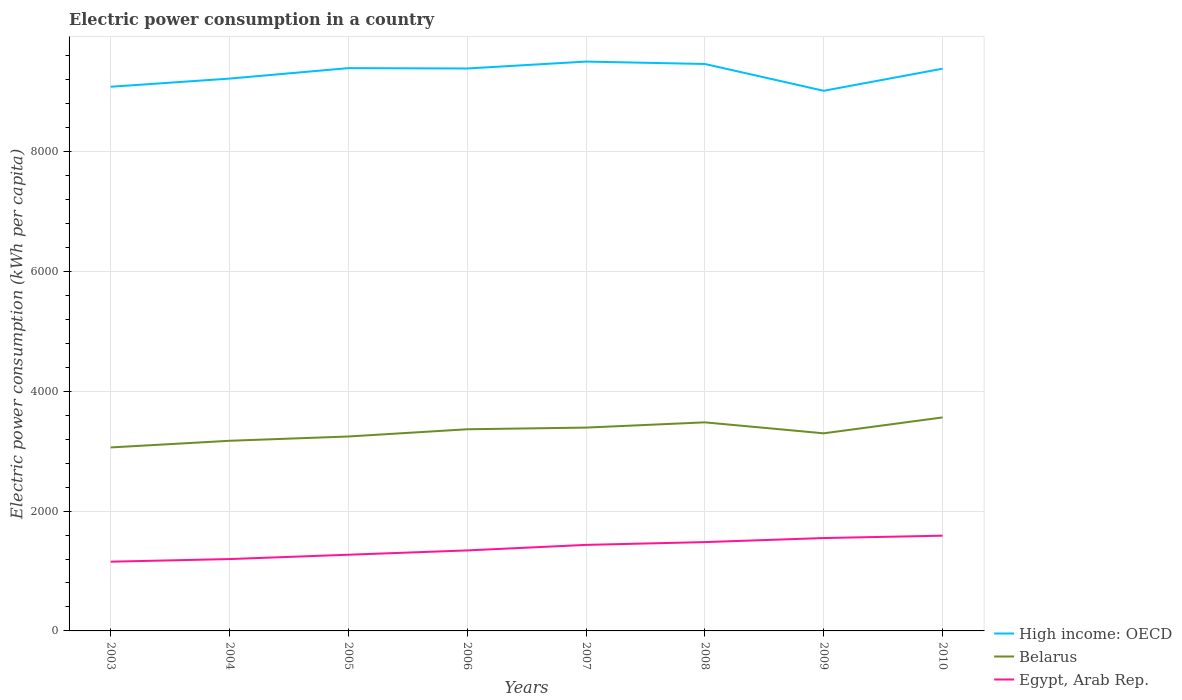How many different coloured lines are there?
Make the answer very short. 3. Is the number of lines equal to the number of legend labels?
Offer a terse response. Yes. Across all years, what is the maximum electric power consumption in in High income: OECD?
Your answer should be compact. 9016.62. In which year was the electric power consumption in in High income: OECD maximum?
Provide a succinct answer. 2009. What is the total electric power consumption in in Egypt, Arab Rep. in the graph?
Ensure brevity in your answer.  -236.49. What is the difference between the highest and the second highest electric power consumption in in Egypt, Arab Rep.?
Offer a very short reply. 434.06. What is the difference between two consecutive major ticks on the Y-axis?
Your answer should be compact. 2000. Are the values on the major ticks of Y-axis written in scientific E-notation?
Ensure brevity in your answer.  No. Where does the legend appear in the graph?
Give a very brief answer. Bottom right. How are the legend labels stacked?
Offer a very short reply. Vertical. What is the title of the graph?
Offer a terse response. Electric power consumption in a country. What is the label or title of the X-axis?
Make the answer very short. Years. What is the label or title of the Y-axis?
Offer a terse response. Electric power consumption (kWh per capita). What is the Electric power consumption (kWh per capita) of High income: OECD in 2003?
Your response must be concise. 9084.07. What is the Electric power consumption (kWh per capita) of Belarus in 2003?
Provide a short and direct response. 3062.98. What is the Electric power consumption (kWh per capita) in Egypt, Arab Rep. in 2003?
Your response must be concise. 1155.82. What is the Electric power consumption (kWh per capita) of High income: OECD in 2004?
Your answer should be very brief. 9220.23. What is the Electric power consumption (kWh per capita) in Belarus in 2004?
Ensure brevity in your answer.  3174.1. What is the Electric power consumption (kWh per capita) in Egypt, Arab Rep. in 2004?
Your response must be concise. 1199.59. What is the Electric power consumption (kWh per capita) of High income: OECD in 2005?
Provide a succinct answer. 9394.97. What is the Electric power consumption (kWh per capita) in Belarus in 2005?
Offer a very short reply. 3245.68. What is the Electric power consumption (kWh per capita) of Egypt, Arab Rep. in 2005?
Ensure brevity in your answer.  1271.75. What is the Electric power consumption (kWh per capita) in High income: OECD in 2006?
Make the answer very short. 9388.91. What is the Electric power consumption (kWh per capita) of Belarus in 2006?
Make the answer very short. 3366.31. What is the Electric power consumption (kWh per capita) of Egypt, Arab Rep. in 2006?
Your answer should be very brief. 1343.77. What is the Electric power consumption (kWh per capita) of High income: OECD in 2007?
Your answer should be compact. 9504.23. What is the Electric power consumption (kWh per capita) in Belarus in 2007?
Your answer should be very brief. 3394.25. What is the Electric power consumption (kWh per capita) in Egypt, Arab Rep. in 2007?
Keep it short and to the point. 1436.07. What is the Electric power consumption (kWh per capita) of High income: OECD in 2008?
Provide a short and direct response. 9464.13. What is the Electric power consumption (kWh per capita) in Belarus in 2008?
Provide a short and direct response. 3481.74. What is the Electric power consumption (kWh per capita) in Egypt, Arab Rep. in 2008?
Your answer should be very brief. 1482.85. What is the Electric power consumption (kWh per capita) of High income: OECD in 2009?
Your response must be concise. 9016.62. What is the Electric power consumption (kWh per capita) in Belarus in 2009?
Ensure brevity in your answer.  3298.62. What is the Electric power consumption (kWh per capita) of Egypt, Arab Rep. in 2009?
Provide a short and direct response. 1550.49. What is the Electric power consumption (kWh per capita) of High income: OECD in 2010?
Offer a very short reply. 9385.25. What is the Electric power consumption (kWh per capita) in Belarus in 2010?
Ensure brevity in your answer.  3563.86. What is the Electric power consumption (kWh per capita) in Egypt, Arab Rep. in 2010?
Offer a very short reply. 1589.88. Across all years, what is the maximum Electric power consumption (kWh per capita) in High income: OECD?
Provide a succinct answer. 9504.23. Across all years, what is the maximum Electric power consumption (kWh per capita) in Belarus?
Your answer should be very brief. 3563.86. Across all years, what is the maximum Electric power consumption (kWh per capita) in Egypt, Arab Rep.?
Offer a terse response. 1589.88. Across all years, what is the minimum Electric power consumption (kWh per capita) in High income: OECD?
Make the answer very short. 9016.62. Across all years, what is the minimum Electric power consumption (kWh per capita) in Belarus?
Keep it short and to the point. 3062.98. Across all years, what is the minimum Electric power consumption (kWh per capita) in Egypt, Arab Rep.?
Offer a terse response. 1155.82. What is the total Electric power consumption (kWh per capita) in High income: OECD in the graph?
Offer a very short reply. 7.45e+04. What is the total Electric power consumption (kWh per capita) of Belarus in the graph?
Your answer should be compact. 2.66e+04. What is the total Electric power consumption (kWh per capita) in Egypt, Arab Rep. in the graph?
Your answer should be very brief. 1.10e+04. What is the difference between the Electric power consumption (kWh per capita) of High income: OECD in 2003 and that in 2004?
Keep it short and to the point. -136.15. What is the difference between the Electric power consumption (kWh per capita) of Belarus in 2003 and that in 2004?
Your answer should be compact. -111.12. What is the difference between the Electric power consumption (kWh per capita) of Egypt, Arab Rep. in 2003 and that in 2004?
Offer a very short reply. -43.77. What is the difference between the Electric power consumption (kWh per capita) in High income: OECD in 2003 and that in 2005?
Provide a short and direct response. -310.9. What is the difference between the Electric power consumption (kWh per capita) in Belarus in 2003 and that in 2005?
Make the answer very short. -182.7. What is the difference between the Electric power consumption (kWh per capita) of Egypt, Arab Rep. in 2003 and that in 2005?
Provide a short and direct response. -115.94. What is the difference between the Electric power consumption (kWh per capita) of High income: OECD in 2003 and that in 2006?
Your response must be concise. -304.84. What is the difference between the Electric power consumption (kWh per capita) in Belarus in 2003 and that in 2006?
Provide a short and direct response. -303.33. What is the difference between the Electric power consumption (kWh per capita) of Egypt, Arab Rep. in 2003 and that in 2006?
Provide a succinct answer. -187.95. What is the difference between the Electric power consumption (kWh per capita) in High income: OECD in 2003 and that in 2007?
Make the answer very short. -420.15. What is the difference between the Electric power consumption (kWh per capita) in Belarus in 2003 and that in 2007?
Your answer should be compact. -331.27. What is the difference between the Electric power consumption (kWh per capita) in Egypt, Arab Rep. in 2003 and that in 2007?
Your answer should be very brief. -280.26. What is the difference between the Electric power consumption (kWh per capita) of High income: OECD in 2003 and that in 2008?
Offer a terse response. -380.05. What is the difference between the Electric power consumption (kWh per capita) of Belarus in 2003 and that in 2008?
Keep it short and to the point. -418.76. What is the difference between the Electric power consumption (kWh per capita) of Egypt, Arab Rep. in 2003 and that in 2008?
Keep it short and to the point. -327.04. What is the difference between the Electric power consumption (kWh per capita) of High income: OECD in 2003 and that in 2009?
Provide a short and direct response. 67.46. What is the difference between the Electric power consumption (kWh per capita) of Belarus in 2003 and that in 2009?
Your answer should be very brief. -235.64. What is the difference between the Electric power consumption (kWh per capita) of Egypt, Arab Rep. in 2003 and that in 2009?
Provide a short and direct response. -394.67. What is the difference between the Electric power consumption (kWh per capita) of High income: OECD in 2003 and that in 2010?
Provide a short and direct response. -301.18. What is the difference between the Electric power consumption (kWh per capita) of Belarus in 2003 and that in 2010?
Provide a short and direct response. -500.88. What is the difference between the Electric power consumption (kWh per capita) in Egypt, Arab Rep. in 2003 and that in 2010?
Keep it short and to the point. -434.06. What is the difference between the Electric power consumption (kWh per capita) in High income: OECD in 2004 and that in 2005?
Provide a short and direct response. -174.75. What is the difference between the Electric power consumption (kWh per capita) in Belarus in 2004 and that in 2005?
Provide a short and direct response. -71.58. What is the difference between the Electric power consumption (kWh per capita) in Egypt, Arab Rep. in 2004 and that in 2005?
Give a very brief answer. -72.17. What is the difference between the Electric power consumption (kWh per capita) in High income: OECD in 2004 and that in 2006?
Your answer should be compact. -168.69. What is the difference between the Electric power consumption (kWh per capita) in Belarus in 2004 and that in 2006?
Make the answer very short. -192.21. What is the difference between the Electric power consumption (kWh per capita) of Egypt, Arab Rep. in 2004 and that in 2006?
Make the answer very short. -144.18. What is the difference between the Electric power consumption (kWh per capita) in High income: OECD in 2004 and that in 2007?
Ensure brevity in your answer.  -284. What is the difference between the Electric power consumption (kWh per capita) in Belarus in 2004 and that in 2007?
Provide a succinct answer. -220.15. What is the difference between the Electric power consumption (kWh per capita) of Egypt, Arab Rep. in 2004 and that in 2007?
Offer a very short reply. -236.49. What is the difference between the Electric power consumption (kWh per capita) of High income: OECD in 2004 and that in 2008?
Make the answer very short. -243.9. What is the difference between the Electric power consumption (kWh per capita) in Belarus in 2004 and that in 2008?
Ensure brevity in your answer.  -307.64. What is the difference between the Electric power consumption (kWh per capita) of Egypt, Arab Rep. in 2004 and that in 2008?
Provide a succinct answer. -283.26. What is the difference between the Electric power consumption (kWh per capita) of High income: OECD in 2004 and that in 2009?
Offer a very short reply. 203.61. What is the difference between the Electric power consumption (kWh per capita) in Belarus in 2004 and that in 2009?
Offer a very short reply. -124.52. What is the difference between the Electric power consumption (kWh per capita) of Egypt, Arab Rep. in 2004 and that in 2009?
Keep it short and to the point. -350.9. What is the difference between the Electric power consumption (kWh per capita) in High income: OECD in 2004 and that in 2010?
Keep it short and to the point. -165.02. What is the difference between the Electric power consumption (kWh per capita) of Belarus in 2004 and that in 2010?
Your response must be concise. -389.76. What is the difference between the Electric power consumption (kWh per capita) in Egypt, Arab Rep. in 2004 and that in 2010?
Provide a succinct answer. -390.29. What is the difference between the Electric power consumption (kWh per capita) in High income: OECD in 2005 and that in 2006?
Offer a terse response. 6.06. What is the difference between the Electric power consumption (kWh per capita) in Belarus in 2005 and that in 2006?
Ensure brevity in your answer.  -120.63. What is the difference between the Electric power consumption (kWh per capita) in Egypt, Arab Rep. in 2005 and that in 2006?
Provide a succinct answer. -72.01. What is the difference between the Electric power consumption (kWh per capita) of High income: OECD in 2005 and that in 2007?
Provide a succinct answer. -109.25. What is the difference between the Electric power consumption (kWh per capita) in Belarus in 2005 and that in 2007?
Your response must be concise. -148.57. What is the difference between the Electric power consumption (kWh per capita) in Egypt, Arab Rep. in 2005 and that in 2007?
Your answer should be compact. -164.32. What is the difference between the Electric power consumption (kWh per capita) in High income: OECD in 2005 and that in 2008?
Ensure brevity in your answer.  -69.16. What is the difference between the Electric power consumption (kWh per capita) of Belarus in 2005 and that in 2008?
Make the answer very short. -236.06. What is the difference between the Electric power consumption (kWh per capita) of Egypt, Arab Rep. in 2005 and that in 2008?
Keep it short and to the point. -211.1. What is the difference between the Electric power consumption (kWh per capita) in High income: OECD in 2005 and that in 2009?
Make the answer very short. 378.36. What is the difference between the Electric power consumption (kWh per capita) in Belarus in 2005 and that in 2009?
Offer a very short reply. -52.94. What is the difference between the Electric power consumption (kWh per capita) of Egypt, Arab Rep. in 2005 and that in 2009?
Offer a terse response. -278.73. What is the difference between the Electric power consumption (kWh per capita) in High income: OECD in 2005 and that in 2010?
Offer a terse response. 9.72. What is the difference between the Electric power consumption (kWh per capita) of Belarus in 2005 and that in 2010?
Ensure brevity in your answer.  -318.18. What is the difference between the Electric power consumption (kWh per capita) in Egypt, Arab Rep. in 2005 and that in 2010?
Offer a very short reply. -318.12. What is the difference between the Electric power consumption (kWh per capita) of High income: OECD in 2006 and that in 2007?
Keep it short and to the point. -115.31. What is the difference between the Electric power consumption (kWh per capita) of Belarus in 2006 and that in 2007?
Provide a short and direct response. -27.94. What is the difference between the Electric power consumption (kWh per capita) of Egypt, Arab Rep. in 2006 and that in 2007?
Your answer should be very brief. -92.31. What is the difference between the Electric power consumption (kWh per capita) in High income: OECD in 2006 and that in 2008?
Your answer should be very brief. -75.21. What is the difference between the Electric power consumption (kWh per capita) of Belarus in 2006 and that in 2008?
Provide a short and direct response. -115.43. What is the difference between the Electric power consumption (kWh per capita) in Egypt, Arab Rep. in 2006 and that in 2008?
Keep it short and to the point. -139.08. What is the difference between the Electric power consumption (kWh per capita) in High income: OECD in 2006 and that in 2009?
Offer a very short reply. 372.3. What is the difference between the Electric power consumption (kWh per capita) of Belarus in 2006 and that in 2009?
Your answer should be compact. 67.68. What is the difference between the Electric power consumption (kWh per capita) in Egypt, Arab Rep. in 2006 and that in 2009?
Provide a succinct answer. -206.72. What is the difference between the Electric power consumption (kWh per capita) of High income: OECD in 2006 and that in 2010?
Give a very brief answer. 3.66. What is the difference between the Electric power consumption (kWh per capita) of Belarus in 2006 and that in 2010?
Your answer should be compact. -197.55. What is the difference between the Electric power consumption (kWh per capita) in Egypt, Arab Rep. in 2006 and that in 2010?
Offer a terse response. -246.11. What is the difference between the Electric power consumption (kWh per capita) in High income: OECD in 2007 and that in 2008?
Your response must be concise. 40.1. What is the difference between the Electric power consumption (kWh per capita) in Belarus in 2007 and that in 2008?
Provide a succinct answer. -87.49. What is the difference between the Electric power consumption (kWh per capita) in Egypt, Arab Rep. in 2007 and that in 2008?
Offer a very short reply. -46.78. What is the difference between the Electric power consumption (kWh per capita) of High income: OECD in 2007 and that in 2009?
Your response must be concise. 487.61. What is the difference between the Electric power consumption (kWh per capita) in Belarus in 2007 and that in 2009?
Make the answer very short. 95.62. What is the difference between the Electric power consumption (kWh per capita) of Egypt, Arab Rep. in 2007 and that in 2009?
Keep it short and to the point. -114.41. What is the difference between the Electric power consumption (kWh per capita) of High income: OECD in 2007 and that in 2010?
Provide a short and direct response. 118.97. What is the difference between the Electric power consumption (kWh per capita) in Belarus in 2007 and that in 2010?
Keep it short and to the point. -169.61. What is the difference between the Electric power consumption (kWh per capita) of Egypt, Arab Rep. in 2007 and that in 2010?
Offer a very short reply. -153.8. What is the difference between the Electric power consumption (kWh per capita) of High income: OECD in 2008 and that in 2009?
Keep it short and to the point. 447.51. What is the difference between the Electric power consumption (kWh per capita) in Belarus in 2008 and that in 2009?
Your answer should be compact. 183.12. What is the difference between the Electric power consumption (kWh per capita) in Egypt, Arab Rep. in 2008 and that in 2009?
Ensure brevity in your answer.  -67.63. What is the difference between the Electric power consumption (kWh per capita) in High income: OECD in 2008 and that in 2010?
Offer a terse response. 78.88. What is the difference between the Electric power consumption (kWh per capita) of Belarus in 2008 and that in 2010?
Provide a succinct answer. -82.12. What is the difference between the Electric power consumption (kWh per capita) of Egypt, Arab Rep. in 2008 and that in 2010?
Offer a terse response. -107.02. What is the difference between the Electric power consumption (kWh per capita) in High income: OECD in 2009 and that in 2010?
Keep it short and to the point. -368.63. What is the difference between the Electric power consumption (kWh per capita) in Belarus in 2009 and that in 2010?
Offer a very short reply. -265.23. What is the difference between the Electric power consumption (kWh per capita) of Egypt, Arab Rep. in 2009 and that in 2010?
Offer a very short reply. -39.39. What is the difference between the Electric power consumption (kWh per capita) of High income: OECD in 2003 and the Electric power consumption (kWh per capita) of Belarus in 2004?
Provide a succinct answer. 5909.97. What is the difference between the Electric power consumption (kWh per capita) in High income: OECD in 2003 and the Electric power consumption (kWh per capita) in Egypt, Arab Rep. in 2004?
Offer a terse response. 7884.49. What is the difference between the Electric power consumption (kWh per capita) in Belarus in 2003 and the Electric power consumption (kWh per capita) in Egypt, Arab Rep. in 2004?
Offer a terse response. 1863.39. What is the difference between the Electric power consumption (kWh per capita) of High income: OECD in 2003 and the Electric power consumption (kWh per capita) of Belarus in 2005?
Offer a terse response. 5838.39. What is the difference between the Electric power consumption (kWh per capita) of High income: OECD in 2003 and the Electric power consumption (kWh per capita) of Egypt, Arab Rep. in 2005?
Give a very brief answer. 7812.32. What is the difference between the Electric power consumption (kWh per capita) in Belarus in 2003 and the Electric power consumption (kWh per capita) in Egypt, Arab Rep. in 2005?
Make the answer very short. 1791.22. What is the difference between the Electric power consumption (kWh per capita) of High income: OECD in 2003 and the Electric power consumption (kWh per capita) of Belarus in 2006?
Offer a terse response. 5717.77. What is the difference between the Electric power consumption (kWh per capita) of High income: OECD in 2003 and the Electric power consumption (kWh per capita) of Egypt, Arab Rep. in 2006?
Provide a succinct answer. 7740.31. What is the difference between the Electric power consumption (kWh per capita) in Belarus in 2003 and the Electric power consumption (kWh per capita) in Egypt, Arab Rep. in 2006?
Make the answer very short. 1719.21. What is the difference between the Electric power consumption (kWh per capita) of High income: OECD in 2003 and the Electric power consumption (kWh per capita) of Belarus in 2007?
Offer a terse response. 5689.83. What is the difference between the Electric power consumption (kWh per capita) in High income: OECD in 2003 and the Electric power consumption (kWh per capita) in Egypt, Arab Rep. in 2007?
Your response must be concise. 7648. What is the difference between the Electric power consumption (kWh per capita) of Belarus in 2003 and the Electric power consumption (kWh per capita) of Egypt, Arab Rep. in 2007?
Ensure brevity in your answer.  1626.9. What is the difference between the Electric power consumption (kWh per capita) of High income: OECD in 2003 and the Electric power consumption (kWh per capita) of Belarus in 2008?
Your answer should be compact. 5602.34. What is the difference between the Electric power consumption (kWh per capita) in High income: OECD in 2003 and the Electric power consumption (kWh per capita) in Egypt, Arab Rep. in 2008?
Provide a short and direct response. 7601.22. What is the difference between the Electric power consumption (kWh per capita) in Belarus in 2003 and the Electric power consumption (kWh per capita) in Egypt, Arab Rep. in 2008?
Give a very brief answer. 1580.13. What is the difference between the Electric power consumption (kWh per capita) in High income: OECD in 2003 and the Electric power consumption (kWh per capita) in Belarus in 2009?
Ensure brevity in your answer.  5785.45. What is the difference between the Electric power consumption (kWh per capita) of High income: OECD in 2003 and the Electric power consumption (kWh per capita) of Egypt, Arab Rep. in 2009?
Your response must be concise. 7533.59. What is the difference between the Electric power consumption (kWh per capita) in Belarus in 2003 and the Electric power consumption (kWh per capita) in Egypt, Arab Rep. in 2009?
Give a very brief answer. 1512.49. What is the difference between the Electric power consumption (kWh per capita) in High income: OECD in 2003 and the Electric power consumption (kWh per capita) in Belarus in 2010?
Keep it short and to the point. 5520.22. What is the difference between the Electric power consumption (kWh per capita) of High income: OECD in 2003 and the Electric power consumption (kWh per capita) of Egypt, Arab Rep. in 2010?
Keep it short and to the point. 7494.2. What is the difference between the Electric power consumption (kWh per capita) of Belarus in 2003 and the Electric power consumption (kWh per capita) of Egypt, Arab Rep. in 2010?
Keep it short and to the point. 1473.1. What is the difference between the Electric power consumption (kWh per capita) in High income: OECD in 2004 and the Electric power consumption (kWh per capita) in Belarus in 2005?
Provide a short and direct response. 5974.55. What is the difference between the Electric power consumption (kWh per capita) in High income: OECD in 2004 and the Electric power consumption (kWh per capita) in Egypt, Arab Rep. in 2005?
Your answer should be very brief. 7948.47. What is the difference between the Electric power consumption (kWh per capita) of Belarus in 2004 and the Electric power consumption (kWh per capita) of Egypt, Arab Rep. in 2005?
Give a very brief answer. 1902.35. What is the difference between the Electric power consumption (kWh per capita) of High income: OECD in 2004 and the Electric power consumption (kWh per capita) of Belarus in 2006?
Provide a short and direct response. 5853.92. What is the difference between the Electric power consumption (kWh per capita) in High income: OECD in 2004 and the Electric power consumption (kWh per capita) in Egypt, Arab Rep. in 2006?
Offer a terse response. 7876.46. What is the difference between the Electric power consumption (kWh per capita) of Belarus in 2004 and the Electric power consumption (kWh per capita) of Egypt, Arab Rep. in 2006?
Provide a short and direct response. 1830.33. What is the difference between the Electric power consumption (kWh per capita) in High income: OECD in 2004 and the Electric power consumption (kWh per capita) in Belarus in 2007?
Your answer should be very brief. 5825.98. What is the difference between the Electric power consumption (kWh per capita) in High income: OECD in 2004 and the Electric power consumption (kWh per capita) in Egypt, Arab Rep. in 2007?
Provide a short and direct response. 7784.15. What is the difference between the Electric power consumption (kWh per capita) in Belarus in 2004 and the Electric power consumption (kWh per capita) in Egypt, Arab Rep. in 2007?
Your response must be concise. 1738.03. What is the difference between the Electric power consumption (kWh per capita) of High income: OECD in 2004 and the Electric power consumption (kWh per capita) of Belarus in 2008?
Ensure brevity in your answer.  5738.49. What is the difference between the Electric power consumption (kWh per capita) in High income: OECD in 2004 and the Electric power consumption (kWh per capita) in Egypt, Arab Rep. in 2008?
Keep it short and to the point. 7737.37. What is the difference between the Electric power consumption (kWh per capita) in Belarus in 2004 and the Electric power consumption (kWh per capita) in Egypt, Arab Rep. in 2008?
Your answer should be compact. 1691.25. What is the difference between the Electric power consumption (kWh per capita) in High income: OECD in 2004 and the Electric power consumption (kWh per capita) in Belarus in 2009?
Keep it short and to the point. 5921.6. What is the difference between the Electric power consumption (kWh per capita) in High income: OECD in 2004 and the Electric power consumption (kWh per capita) in Egypt, Arab Rep. in 2009?
Keep it short and to the point. 7669.74. What is the difference between the Electric power consumption (kWh per capita) in Belarus in 2004 and the Electric power consumption (kWh per capita) in Egypt, Arab Rep. in 2009?
Offer a very short reply. 1623.61. What is the difference between the Electric power consumption (kWh per capita) of High income: OECD in 2004 and the Electric power consumption (kWh per capita) of Belarus in 2010?
Provide a succinct answer. 5656.37. What is the difference between the Electric power consumption (kWh per capita) of High income: OECD in 2004 and the Electric power consumption (kWh per capita) of Egypt, Arab Rep. in 2010?
Keep it short and to the point. 7630.35. What is the difference between the Electric power consumption (kWh per capita) in Belarus in 2004 and the Electric power consumption (kWh per capita) in Egypt, Arab Rep. in 2010?
Make the answer very short. 1584.22. What is the difference between the Electric power consumption (kWh per capita) of High income: OECD in 2005 and the Electric power consumption (kWh per capita) of Belarus in 2006?
Make the answer very short. 6028.67. What is the difference between the Electric power consumption (kWh per capita) of High income: OECD in 2005 and the Electric power consumption (kWh per capita) of Egypt, Arab Rep. in 2006?
Your response must be concise. 8051.2. What is the difference between the Electric power consumption (kWh per capita) of Belarus in 2005 and the Electric power consumption (kWh per capita) of Egypt, Arab Rep. in 2006?
Your answer should be compact. 1901.91. What is the difference between the Electric power consumption (kWh per capita) in High income: OECD in 2005 and the Electric power consumption (kWh per capita) in Belarus in 2007?
Provide a short and direct response. 6000.73. What is the difference between the Electric power consumption (kWh per capita) of High income: OECD in 2005 and the Electric power consumption (kWh per capita) of Egypt, Arab Rep. in 2007?
Offer a very short reply. 7958.9. What is the difference between the Electric power consumption (kWh per capita) of Belarus in 2005 and the Electric power consumption (kWh per capita) of Egypt, Arab Rep. in 2007?
Your answer should be compact. 1809.61. What is the difference between the Electric power consumption (kWh per capita) in High income: OECD in 2005 and the Electric power consumption (kWh per capita) in Belarus in 2008?
Make the answer very short. 5913.23. What is the difference between the Electric power consumption (kWh per capita) of High income: OECD in 2005 and the Electric power consumption (kWh per capita) of Egypt, Arab Rep. in 2008?
Provide a short and direct response. 7912.12. What is the difference between the Electric power consumption (kWh per capita) of Belarus in 2005 and the Electric power consumption (kWh per capita) of Egypt, Arab Rep. in 2008?
Keep it short and to the point. 1762.83. What is the difference between the Electric power consumption (kWh per capita) of High income: OECD in 2005 and the Electric power consumption (kWh per capita) of Belarus in 2009?
Ensure brevity in your answer.  6096.35. What is the difference between the Electric power consumption (kWh per capita) in High income: OECD in 2005 and the Electric power consumption (kWh per capita) in Egypt, Arab Rep. in 2009?
Your response must be concise. 7844.48. What is the difference between the Electric power consumption (kWh per capita) of Belarus in 2005 and the Electric power consumption (kWh per capita) of Egypt, Arab Rep. in 2009?
Your answer should be compact. 1695.19. What is the difference between the Electric power consumption (kWh per capita) of High income: OECD in 2005 and the Electric power consumption (kWh per capita) of Belarus in 2010?
Your answer should be very brief. 5831.12. What is the difference between the Electric power consumption (kWh per capita) in High income: OECD in 2005 and the Electric power consumption (kWh per capita) in Egypt, Arab Rep. in 2010?
Your response must be concise. 7805.1. What is the difference between the Electric power consumption (kWh per capita) of Belarus in 2005 and the Electric power consumption (kWh per capita) of Egypt, Arab Rep. in 2010?
Keep it short and to the point. 1655.8. What is the difference between the Electric power consumption (kWh per capita) in High income: OECD in 2006 and the Electric power consumption (kWh per capita) in Belarus in 2007?
Ensure brevity in your answer.  5994.67. What is the difference between the Electric power consumption (kWh per capita) of High income: OECD in 2006 and the Electric power consumption (kWh per capita) of Egypt, Arab Rep. in 2007?
Offer a terse response. 7952.84. What is the difference between the Electric power consumption (kWh per capita) of Belarus in 2006 and the Electric power consumption (kWh per capita) of Egypt, Arab Rep. in 2007?
Provide a succinct answer. 1930.23. What is the difference between the Electric power consumption (kWh per capita) of High income: OECD in 2006 and the Electric power consumption (kWh per capita) of Belarus in 2008?
Provide a succinct answer. 5907.18. What is the difference between the Electric power consumption (kWh per capita) of High income: OECD in 2006 and the Electric power consumption (kWh per capita) of Egypt, Arab Rep. in 2008?
Offer a terse response. 7906.06. What is the difference between the Electric power consumption (kWh per capita) in Belarus in 2006 and the Electric power consumption (kWh per capita) in Egypt, Arab Rep. in 2008?
Make the answer very short. 1883.45. What is the difference between the Electric power consumption (kWh per capita) in High income: OECD in 2006 and the Electric power consumption (kWh per capita) in Belarus in 2009?
Your answer should be compact. 6090.29. What is the difference between the Electric power consumption (kWh per capita) of High income: OECD in 2006 and the Electric power consumption (kWh per capita) of Egypt, Arab Rep. in 2009?
Your response must be concise. 7838.43. What is the difference between the Electric power consumption (kWh per capita) of Belarus in 2006 and the Electric power consumption (kWh per capita) of Egypt, Arab Rep. in 2009?
Your answer should be compact. 1815.82. What is the difference between the Electric power consumption (kWh per capita) in High income: OECD in 2006 and the Electric power consumption (kWh per capita) in Belarus in 2010?
Offer a terse response. 5825.06. What is the difference between the Electric power consumption (kWh per capita) in High income: OECD in 2006 and the Electric power consumption (kWh per capita) in Egypt, Arab Rep. in 2010?
Your response must be concise. 7799.04. What is the difference between the Electric power consumption (kWh per capita) of Belarus in 2006 and the Electric power consumption (kWh per capita) of Egypt, Arab Rep. in 2010?
Offer a very short reply. 1776.43. What is the difference between the Electric power consumption (kWh per capita) of High income: OECD in 2007 and the Electric power consumption (kWh per capita) of Belarus in 2008?
Keep it short and to the point. 6022.49. What is the difference between the Electric power consumption (kWh per capita) of High income: OECD in 2007 and the Electric power consumption (kWh per capita) of Egypt, Arab Rep. in 2008?
Provide a succinct answer. 8021.37. What is the difference between the Electric power consumption (kWh per capita) of Belarus in 2007 and the Electric power consumption (kWh per capita) of Egypt, Arab Rep. in 2008?
Your answer should be compact. 1911.39. What is the difference between the Electric power consumption (kWh per capita) in High income: OECD in 2007 and the Electric power consumption (kWh per capita) in Belarus in 2009?
Keep it short and to the point. 6205.6. What is the difference between the Electric power consumption (kWh per capita) in High income: OECD in 2007 and the Electric power consumption (kWh per capita) in Egypt, Arab Rep. in 2009?
Your answer should be compact. 7953.74. What is the difference between the Electric power consumption (kWh per capita) of Belarus in 2007 and the Electric power consumption (kWh per capita) of Egypt, Arab Rep. in 2009?
Your response must be concise. 1843.76. What is the difference between the Electric power consumption (kWh per capita) in High income: OECD in 2007 and the Electric power consumption (kWh per capita) in Belarus in 2010?
Keep it short and to the point. 5940.37. What is the difference between the Electric power consumption (kWh per capita) of High income: OECD in 2007 and the Electric power consumption (kWh per capita) of Egypt, Arab Rep. in 2010?
Your answer should be very brief. 7914.35. What is the difference between the Electric power consumption (kWh per capita) in Belarus in 2007 and the Electric power consumption (kWh per capita) in Egypt, Arab Rep. in 2010?
Ensure brevity in your answer.  1804.37. What is the difference between the Electric power consumption (kWh per capita) of High income: OECD in 2008 and the Electric power consumption (kWh per capita) of Belarus in 2009?
Offer a terse response. 6165.51. What is the difference between the Electric power consumption (kWh per capita) in High income: OECD in 2008 and the Electric power consumption (kWh per capita) in Egypt, Arab Rep. in 2009?
Offer a terse response. 7913.64. What is the difference between the Electric power consumption (kWh per capita) in Belarus in 2008 and the Electric power consumption (kWh per capita) in Egypt, Arab Rep. in 2009?
Make the answer very short. 1931.25. What is the difference between the Electric power consumption (kWh per capita) in High income: OECD in 2008 and the Electric power consumption (kWh per capita) in Belarus in 2010?
Provide a short and direct response. 5900.27. What is the difference between the Electric power consumption (kWh per capita) of High income: OECD in 2008 and the Electric power consumption (kWh per capita) of Egypt, Arab Rep. in 2010?
Ensure brevity in your answer.  7874.25. What is the difference between the Electric power consumption (kWh per capita) in Belarus in 2008 and the Electric power consumption (kWh per capita) in Egypt, Arab Rep. in 2010?
Give a very brief answer. 1891.86. What is the difference between the Electric power consumption (kWh per capita) in High income: OECD in 2009 and the Electric power consumption (kWh per capita) in Belarus in 2010?
Keep it short and to the point. 5452.76. What is the difference between the Electric power consumption (kWh per capita) in High income: OECD in 2009 and the Electric power consumption (kWh per capita) in Egypt, Arab Rep. in 2010?
Keep it short and to the point. 7426.74. What is the difference between the Electric power consumption (kWh per capita) of Belarus in 2009 and the Electric power consumption (kWh per capita) of Egypt, Arab Rep. in 2010?
Your answer should be very brief. 1708.75. What is the average Electric power consumption (kWh per capita) of High income: OECD per year?
Provide a short and direct response. 9307.3. What is the average Electric power consumption (kWh per capita) in Belarus per year?
Make the answer very short. 3323.44. What is the average Electric power consumption (kWh per capita) of Egypt, Arab Rep. per year?
Keep it short and to the point. 1378.78. In the year 2003, what is the difference between the Electric power consumption (kWh per capita) of High income: OECD and Electric power consumption (kWh per capita) of Belarus?
Your response must be concise. 6021.1. In the year 2003, what is the difference between the Electric power consumption (kWh per capita) of High income: OECD and Electric power consumption (kWh per capita) of Egypt, Arab Rep.?
Ensure brevity in your answer.  7928.26. In the year 2003, what is the difference between the Electric power consumption (kWh per capita) in Belarus and Electric power consumption (kWh per capita) in Egypt, Arab Rep.?
Ensure brevity in your answer.  1907.16. In the year 2004, what is the difference between the Electric power consumption (kWh per capita) in High income: OECD and Electric power consumption (kWh per capita) in Belarus?
Offer a terse response. 6046.13. In the year 2004, what is the difference between the Electric power consumption (kWh per capita) in High income: OECD and Electric power consumption (kWh per capita) in Egypt, Arab Rep.?
Keep it short and to the point. 8020.64. In the year 2004, what is the difference between the Electric power consumption (kWh per capita) in Belarus and Electric power consumption (kWh per capita) in Egypt, Arab Rep.?
Ensure brevity in your answer.  1974.51. In the year 2005, what is the difference between the Electric power consumption (kWh per capita) in High income: OECD and Electric power consumption (kWh per capita) in Belarus?
Your answer should be very brief. 6149.29. In the year 2005, what is the difference between the Electric power consumption (kWh per capita) of High income: OECD and Electric power consumption (kWh per capita) of Egypt, Arab Rep.?
Ensure brevity in your answer.  8123.22. In the year 2005, what is the difference between the Electric power consumption (kWh per capita) of Belarus and Electric power consumption (kWh per capita) of Egypt, Arab Rep.?
Keep it short and to the point. 1973.92. In the year 2006, what is the difference between the Electric power consumption (kWh per capita) in High income: OECD and Electric power consumption (kWh per capita) in Belarus?
Give a very brief answer. 6022.61. In the year 2006, what is the difference between the Electric power consumption (kWh per capita) in High income: OECD and Electric power consumption (kWh per capita) in Egypt, Arab Rep.?
Offer a very short reply. 8045.15. In the year 2006, what is the difference between the Electric power consumption (kWh per capita) of Belarus and Electric power consumption (kWh per capita) of Egypt, Arab Rep.?
Your response must be concise. 2022.54. In the year 2007, what is the difference between the Electric power consumption (kWh per capita) in High income: OECD and Electric power consumption (kWh per capita) in Belarus?
Your answer should be very brief. 6109.98. In the year 2007, what is the difference between the Electric power consumption (kWh per capita) of High income: OECD and Electric power consumption (kWh per capita) of Egypt, Arab Rep.?
Your answer should be very brief. 8068.15. In the year 2007, what is the difference between the Electric power consumption (kWh per capita) of Belarus and Electric power consumption (kWh per capita) of Egypt, Arab Rep.?
Make the answer very short. 1958.17. In the year 2008, what is the difference between the Electric power consumption (kWh per capita) of High income: OECD and Electric power consumption (kWh per capita) of Belarus?
Offer a very short reply. 5982.39. In the year 2008, what is the difference between the Electric power consumption (kWh per capita) of High income: OECD and Electric power consumption (kWh per capita) of Egypt, Arab Rep.?
Your answer should be compact. 7981.27. In the year 2008, what is the difference between the Electric power consumption (kWh per capita) of Belarus and Electric power consumption (kWh per capita) of Egypt, Arab Rep.?
Your answer should be compact. 1998.88. In the year 2009, what is the difference between the Electric power consumption (kWh per capita) in High income: OECD and Electric power consumption (kWh per capita) in Belarus?
Your answer should be compact. 5717.99. In the year 2009, what is the difference between the Electric power consumption (kWh per capita) in High income: OECD and Electric power consumption (kWh per capita) in Egypt, Arab Rep.?
Your answer should be very brief. 7466.13. In the year 2009, what is the difference between the Electric power consumption (kWh per capita) of Belarus and Electric power consumption (kWh per capita) of Egypt, Arab Rep.?
Keep it short and to the point. 1748.13. In the year 2010, what is the difference between the Electric power consumption (kWh per capita) of High income: OECD and Electric power consumption (kWh per capita) of Belarus?
Your answer should be very brief. 5821.39. In the year 2010, what is the difference between the Electric power consumption (kWh per capita) of High income: OECD and Electric power consumption (kWh per capita) of Egypt, Arab Rep.?
Give a very brief answer. 7795.37. In the year 2010, what is the difference between the Electric power consumption (kWh per capita) in Belarus and Electric power consumption (kWh per capita) in Egypt, Arab Rep.?
Your response must be concise. 1973.98. What is the ratio of the Electric power consumption (kWh per capita) in High income: OECD in 2003 to that in 2004?
Ensure brevity in your answer.  0.99. What is the ratio of the Electric power consumption (kWh per capita) in Belarus in 2003 to that in 2004?
Offer a terse response. 0.96. What is the ratio of the Electric power consumption (kWh per capita) in Egypt, Arab Rep. in 2003 to that in 2004?
Offer a terse response. 0.96. What is the ratio of the Electric power consumption (kWh per capita) of High income: OECD in 2003 to that in 2005?
Your answer should be very brief. 0.97. What is the ratio of the Electric power consumption (kWh per capita) in Belarus in 2003 to that in 2005?
Your answer should be compact. 0.94. What is the ratio of the Electric power consumption (kWh per capita) of Egypt, Arab Rep. in 2003 to that in 2005?
Your answer should be very brief. 0.91. What is the ratio of the Electric power consumption (kWh per capita) in High income: OECD in 2003 to that in 2006?
Ensure brevity in your answer.  0.97. What is the ratio of the Electric power consumption (kWh per capita) in Belarus in 2003 to that in 2006?
Ensure brevity in your answer.  0.91. What is the ratio of the Electric power consumption (kWh per capita) of Egypt, Arab Rep. in 2003 to that in 2006?
Provide a succinct answer. 0.86. What is the ratio of the Electric power consumption (kWh per capita) of High income: OECD in 2003 to that in 2007?
Keep it short and to the point. 0.96. What is the ratio of the Electric power consumption (kWh per capita) of Belarus in 2003 to that in 2007?
Ensure brevity in your answer.  0.9. What is the ratio of the Electric power consumption (kWh per capita) of Egypt, Arab Rep. in 2003 to that in 2007?
Offer a terse response. 0.8. What is the ratio of the Electric power consumption (kWh per capita) of High income: OECD in 2003 to that in 2008?
Keep it short and to the point. 0.96. What is the ratio of the Electric power consumption (kWh per capita) of Belarus in 2003 to that in 2008?
Your answer should be compact. 0.88. What is the ratio of the Electric power consumption (kWh per capita) of Egypt, Arab Rep. in 2003 to that in 2008?
Offer a very short reply. 0.78. What is the ratio of the Electric power consumption (kWh per capita) of High income: OECD in 2003 to that in 2009?
Your response must be concise. 1.01. What is the ratio of the Electric power consumption (kWh per capita) of Belarus in 2003 to that in 2009?
Keep it short and to the point. 0.93. What is the ratio of the Electric power consumption (kWh per capita) in Egypt, Arab Rep. in 2003 to that in 2009?
Give a very brief answer. 0.75. What is the ratio of the Electric power consumption (kWh per capita) in High income: OECD in 2003 to that in 2010?
Offer a very short reply. 0.97. What is the ratio of the Electric power consumption (kWh per capita) in Belarus in 2003 to that in 2010?
Your answer should be compact. 0.86. What is the ratio of the Electric power consumption (kWh per capita) in Egypt, Arab Rep. in 2003 to that in 2010?
Your response must be concise. 0.73. What is the ratio of the Electric power consumption (kWh per capita) of High income: OECD in 2004 to that in 2005?
Offer a terse response. 0.98. What is the ratio of the Electric power consumption (kWh per capita) in Belarus in 2004 to that in 2005?
Provide a succinct answer. 0.98. What is the ratio of the Electric power consumption (kWh per capita) in Egypt, Arab Rep. in 2004 to that in 2005?
Your answer should be compact. 0.94. What is the ratio of the Electric power consumption (kWh per capita) of Belarus in 2004 to that in 2006?
Provide a succinct answer. 0.94. What is the ratio of the Electric power consumption (kWh per capita) in Egypt, Arab Rep. in 2004 to that in 2006?
Provide a short and direct response. 0.89. What is the ratio of the Electric power consumption (kWh per capita) in High income: OECD in 2004 to that in 2007?
Provide a short and direct response. 0.97. What is the ratio of the Electric power consumption (kWh per capita) in Belarus in 2004 to that in 2007?
Keep it short and to the point. 0.94. What is the ratio of the Electric power consumption (kWh per capita) of Egypt, Arab Rep. in 2004 to that in 2007?
Make the answer very short. 0.84. What is the ratio of the Electric power consumption (kWh per capita) in High income: OECD in 2004 to that in 2008?
Offer a very short reply. 0.97. What is the ratio of the Electric power consumption (kWh per capita) in Belarus in 2004 to that in 2008?
Make the answer very short. 0.91. What is the ratio of the Electric power consumption (kWh per capita) of Egypt, Arab Rep. in 2004 to that in 2008?
Your answer should be compact. 0.81. What is the ratio of the Electric power consumption (kWh per capita) in High income: OECD in 2004 to that in 2009?
Your answer should be very brief. 1.02. What is the ratio of the Electric power consumption (kWh per capita) of Belarus in 2004 to that in 2009?
Your answer should be very brief. 0.96. What is the ratio of the Electric power consumption (kWh per capita) of Egypt, Arab Rep. in 2004 to that in 2009?
Make the answer very short. 0.77. What is the ratio of the Electric power consumption (kWh per capita) of High income: OECD in 2004 to that in 2010?
Your answer should be compact. 0.98. What is the ratio of the Electric power consumption (kWh per capita) in Belarus in 2004 to that in 2010?
Offer a terse response. 0.89. What is the ratio of the Electric power consumption (kWh per capita) of Egypt, Arab Rep. in 2004 to that in 2010?
Keep it short and to the point. 0.75. What is the ratio of the Electric power consumption (kWh per capita) in Belarus in 2005 to that in 2006?
Give a very brief answer. 0.96. What is the ratio of the Electric power consumption (kWh per capita) in Egypt, Arab Rep. in 2005 to that in 2006?
Provide a succinct answer. 0.95. What is the ratio of the Electric power consumption (kWh per capita) in High income: OECD in 2005 to that in 2007?
Keep it short and to the point. 0.99. What is the ratio of the Electric power consumption (kWh per capita) of Belarus in 2005 to that in 2007?
Provide a succinct answer. 0.96. What is the ratio of the Electric power consumption (kWh per capita) of Egypt, Arab Rep. in 2005 to that in 2007?
Ensure brevity in your answer.  0.89. What is the ratio of the Electric power consumption (kWh per capita) in High income: OECD in 2005 to that in 2008?
Offer a terse response. 0.99. What is the ratio of the Electric power consumption (kWh per capita) of Belarus in 2005 to that in 2008?
Give a very brief answer. 0.93. What is the ratio of the Electric power consumption (kWh per capita) of Egypt, Arab Rep. in 2005 to that in 2008?
Give a very brief answer. 0.86. What is the ratio of the Electric power consumption (kWh per capita) of High income: OECD in 2005 to that in 2009?
Your answer should be very brief. 1.04. What is the ratio of the Electric power consumption (kWh per capita) in Belarus in 2005 to that in 2009?
Make the answer very short. 0.98. What is the ratio of the Electric power consumption (kWh per capita) of Egypt, Arab Rep. in 2005 to that in 2009?
Provide a short and direct response. 0.82. What is the ratio of the Electric power consumption (kWh per capita) in High income: OECD in 2005 to that in 2010?
Give a very brief answer. 1. What is the ratio of the Electric power consumption (kWh per capita) in Belarus in 2005 to that in 2010?
Your answer should be very brief. 0.91. What is the ratio of the Electric power consumption (kWh per capita) of Egypt, Arab Rep. in 2005 to that in 2010?
Your answer should be compact. 0.8. What is the ratio of the Electric power consumption (kWh per capita) in High income: OECD in 2006 to that in 2007?
Provide a short and direct response. 0.99. What is the ratio of the Electric power consumption (kWh per capita) in Egypt, Arab Rep. in 2006 to that in 2007?
Offer a terse response. 0.94. What is the ratio of the Electric power consumption (kWh per capita) of Belarus in 2006 to that in 2008?
Offer a terse response. 0.97. What is the ratio of the Electric power consumption (kWh per capita) of Egypt, Arab Rep. in 2006 to that in 2008?
Offer a very short reply. 0.91. What is the ratio of the Electric power consumption (kWh per capita) of High income: OECD in 2006 to that in 2009?
Provide a succinct answer. 1.04. What is the ratio of the Electric power consumption (kWh per capita) in Belarus in 2006 to that in 2009?
Provide a succinct answer. 1.02. What is the ratio of the Electric power consumption (kWh per capita) of Egypt, Arab Rep. in 2006 to that in 2009?
Your answer should be compact. 0.87. What is the ratio of the Electric power consumption (kWh per capita) in High income: OECD in 2006 to that in 2010?
Offer a terse response. 1. What is the ratio of the Electric power consumption (kWh per capita) of Belarus in 2006 to that in 2010?
Offer a terse response. 0.94. What is the ratio of the Electric power consumption (kWh per capita) in Egypt, Arab Rep. in 2006 to that in 2010?
Provide a short and direct response. 0.85. What is the ratio of the Electric power consumption (kWh per capita) in Belarus in 2007 to that in 2008?
Provide a short and direct response. 0.97. What is the ratio of the Electric power consumption (kWh per capita) in Egypt, Arab Rep. in 2007 to that in 2008?
Give a very brief answer. 0.97. What is the ratio of the Electric power consumption (kWh per capita) in High income: OECD in 2007 to that in 2009?
Your response must be concise. 1.05. What is the ratio of the Electric power consumption (kWh per capita) of Belarus in 2007 to that in 2009?
Make the answer very short. 1.03. What is the ratio of the Electric power consumption (kWh per capita) in Egypt, Arab Rep. in 2007 to that in 2009?
Make the answer very short. 0.93. What is the ratio of the Electric power consumption (kWh per capita) in High income: OECD in 2007 to that in 2010?
Your answer should be very brief. 1.01. What is the ratio of the Electric power consumption (kWh per capita) of Belarus in 2007 to that in 2010?
Keep it short and to the point. 0.95. What is the ratio of the Electric power consumption (kWh per capita) in Egypt, Arab Rep. in 2007 to that in 2010?
Offer a terse response. 0.9. What is the ratio of the Electric power consumption (kWh per capita) in High income: OECD in 2008 to that in 2009?
Keep it short and to the point. 1.05. What is the ratio of the Electric power consumption (kWh per capita) of Belarus in 2008 to that in 2009?
Your answer should be compact. 1.06. What is the ratio of the Electric power consumption (kWh per capita) in Egypt, Arab Rep. in 2008 to that in 2009?
Ensure brevity in your answer.  0.96. What is the ratio of the Electric power consumption (kWh per capita) of High income: OECD in 2008 to that in 2010?
Keep it short and to the point. 1.01. What is the ratio of the Electric power consumption (kWh per capita) of Egypt, Arab Rep. in 2008 to that in 2010?
Your response must be concise. 0.93. What is the ratio of the Electric power consumption (kWh per capita) of High income: OECD in 2009 to that in 2010?
Your response must be concise. 0.96. What is the ratio of the Electric power consumption (kWh per capita) of Belarus in 2009 to that in 2010?
Provide a short and direct response. 0.93. What is the ratio of the Electric power consumption (kWh per capita) of Egypt, Arab Rep. in 2009 to that in 2010?
Ensure brevity in your answer.  0.98. What is the difference between the highest and the second highest Electric power consumption (kWh per capita) of High income: OECD?
Offer a very short reply. 40.1. What is the difference between the highest and the second highest Electric power consumption (kWh per capita) of Belarus?
Keep it short and to the point. 82.12. What is the difference between the highest and the second highest Electric power consumption (kWh per capita) in Egypt, Arab Rep.?
Keep it short and to the point. 39.39. What is the difference between the highest and the lowest Electric power consumption (kWh per capita) in High income: OECD?
Offer a terse response. 487.61. What is the difference between the highest and the lowest Electric power consumption (kWh per capita) of Belarus?
Offer a very short reply. 500.88. What is the difference between the highest and the lowest Electric power consumption (kWh per capita) of Egypt, Arab Rep.?
Provide a short and direct response. 434.06. 